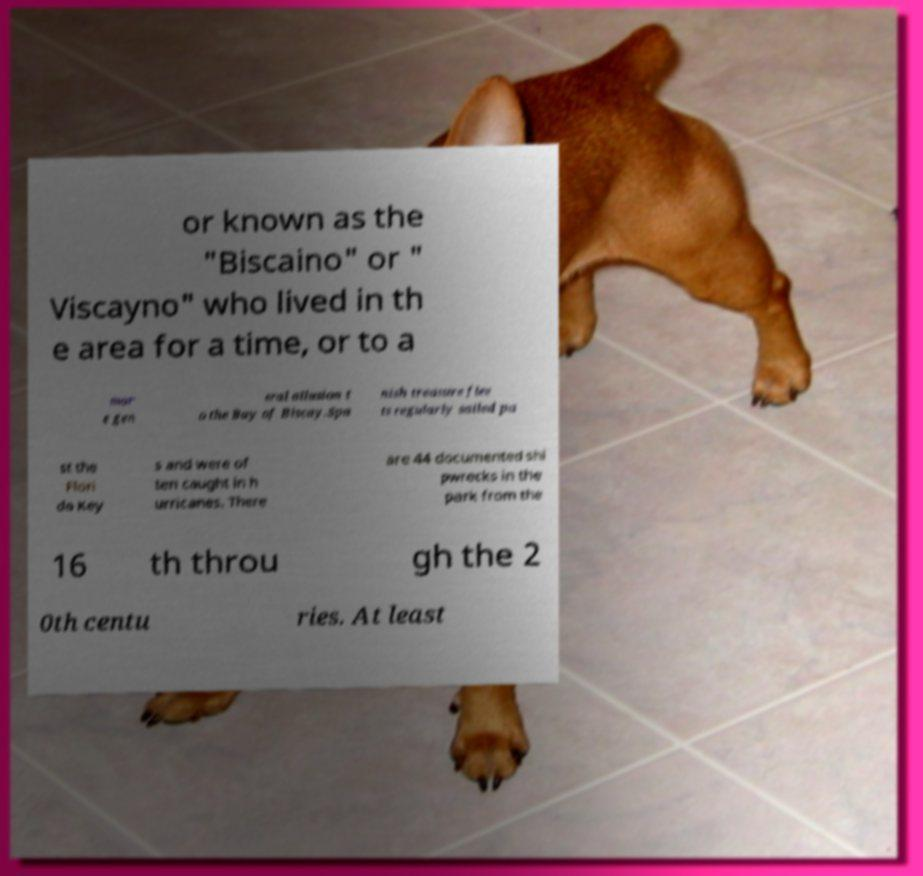Could you assist in decoding the text presented in this image and type it out clearly? or known as the "Biscaino" or " Viscayno" who lived in th e area for a time, or to a mor e gen eral allusion t o the Bay of Biscay.Spa nish treasure flee ts regularly sailed pa st the Flori da Key s and were of ten caught in h urricanes. There are 44 documented shi pwrecks in the park from the 16 th throu gh the 2 0th centu ries. At least 